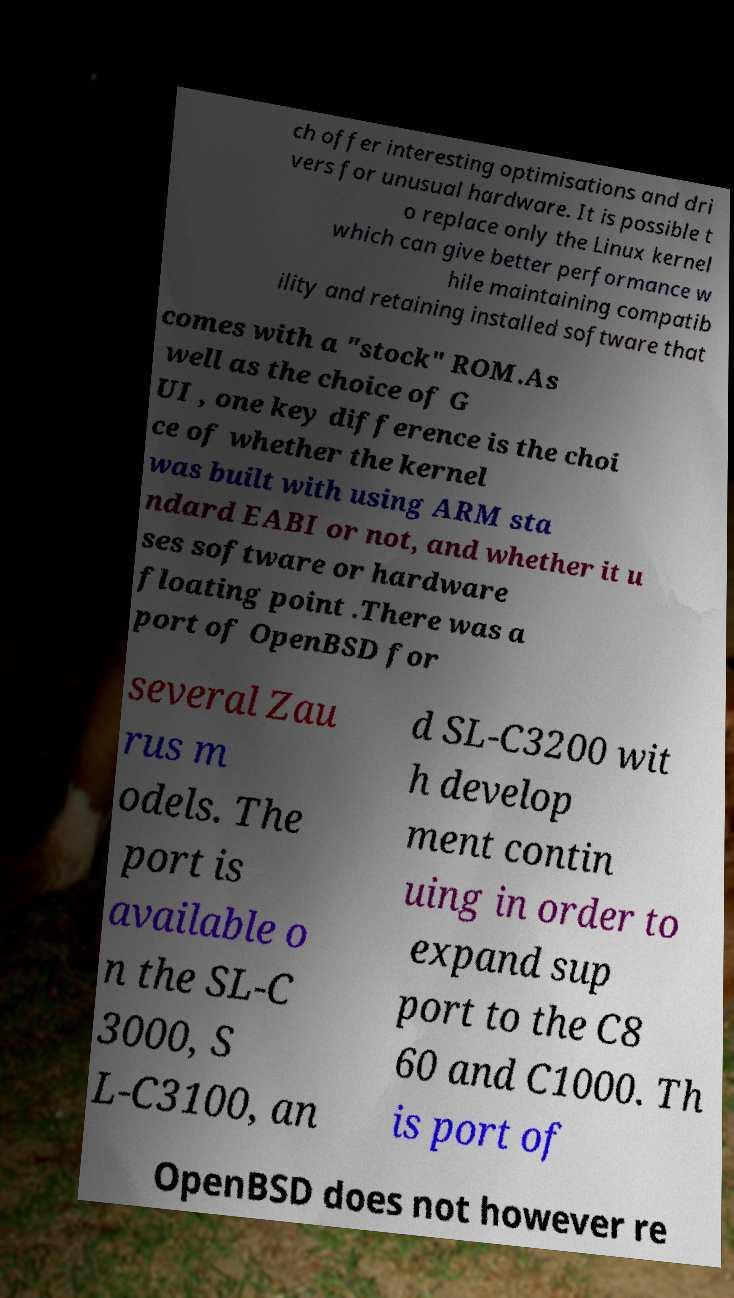Can you read and provide the text displayed in the image?This photo seems to have some interesting text. Can you extract and type it out for me? ch offer interesting optimisations and dri vers for unusual hardware. It is possible t o replace only the Linux kernel which can give better performance w hile maintaining compatib ility and retaining installed software that comes with a "stock" ROM.As well as the choice of G UI , one key difference is the choi ce of whether the kernel was built with using ARM sta ndard EABI or not, and whether it u ses software or hardware floating point .There was a port of OpenBSD for several Zau rus m odels. The port is available o n the SL-C 3000, S L-C3100, an d SL-C3200 wit h develop ment contin uing in order to expand sup port to the C8 60 and C1000. Th is port of OpenBSD does not however re 